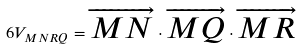<formula> <loc_0><loc_0><loc_500><loc_500>6 V _ { M N R Q } = \overrightarrow { M N } \cdot \overrightarrow { M Q } \cdot \overrightarrow { M R }</formula> 